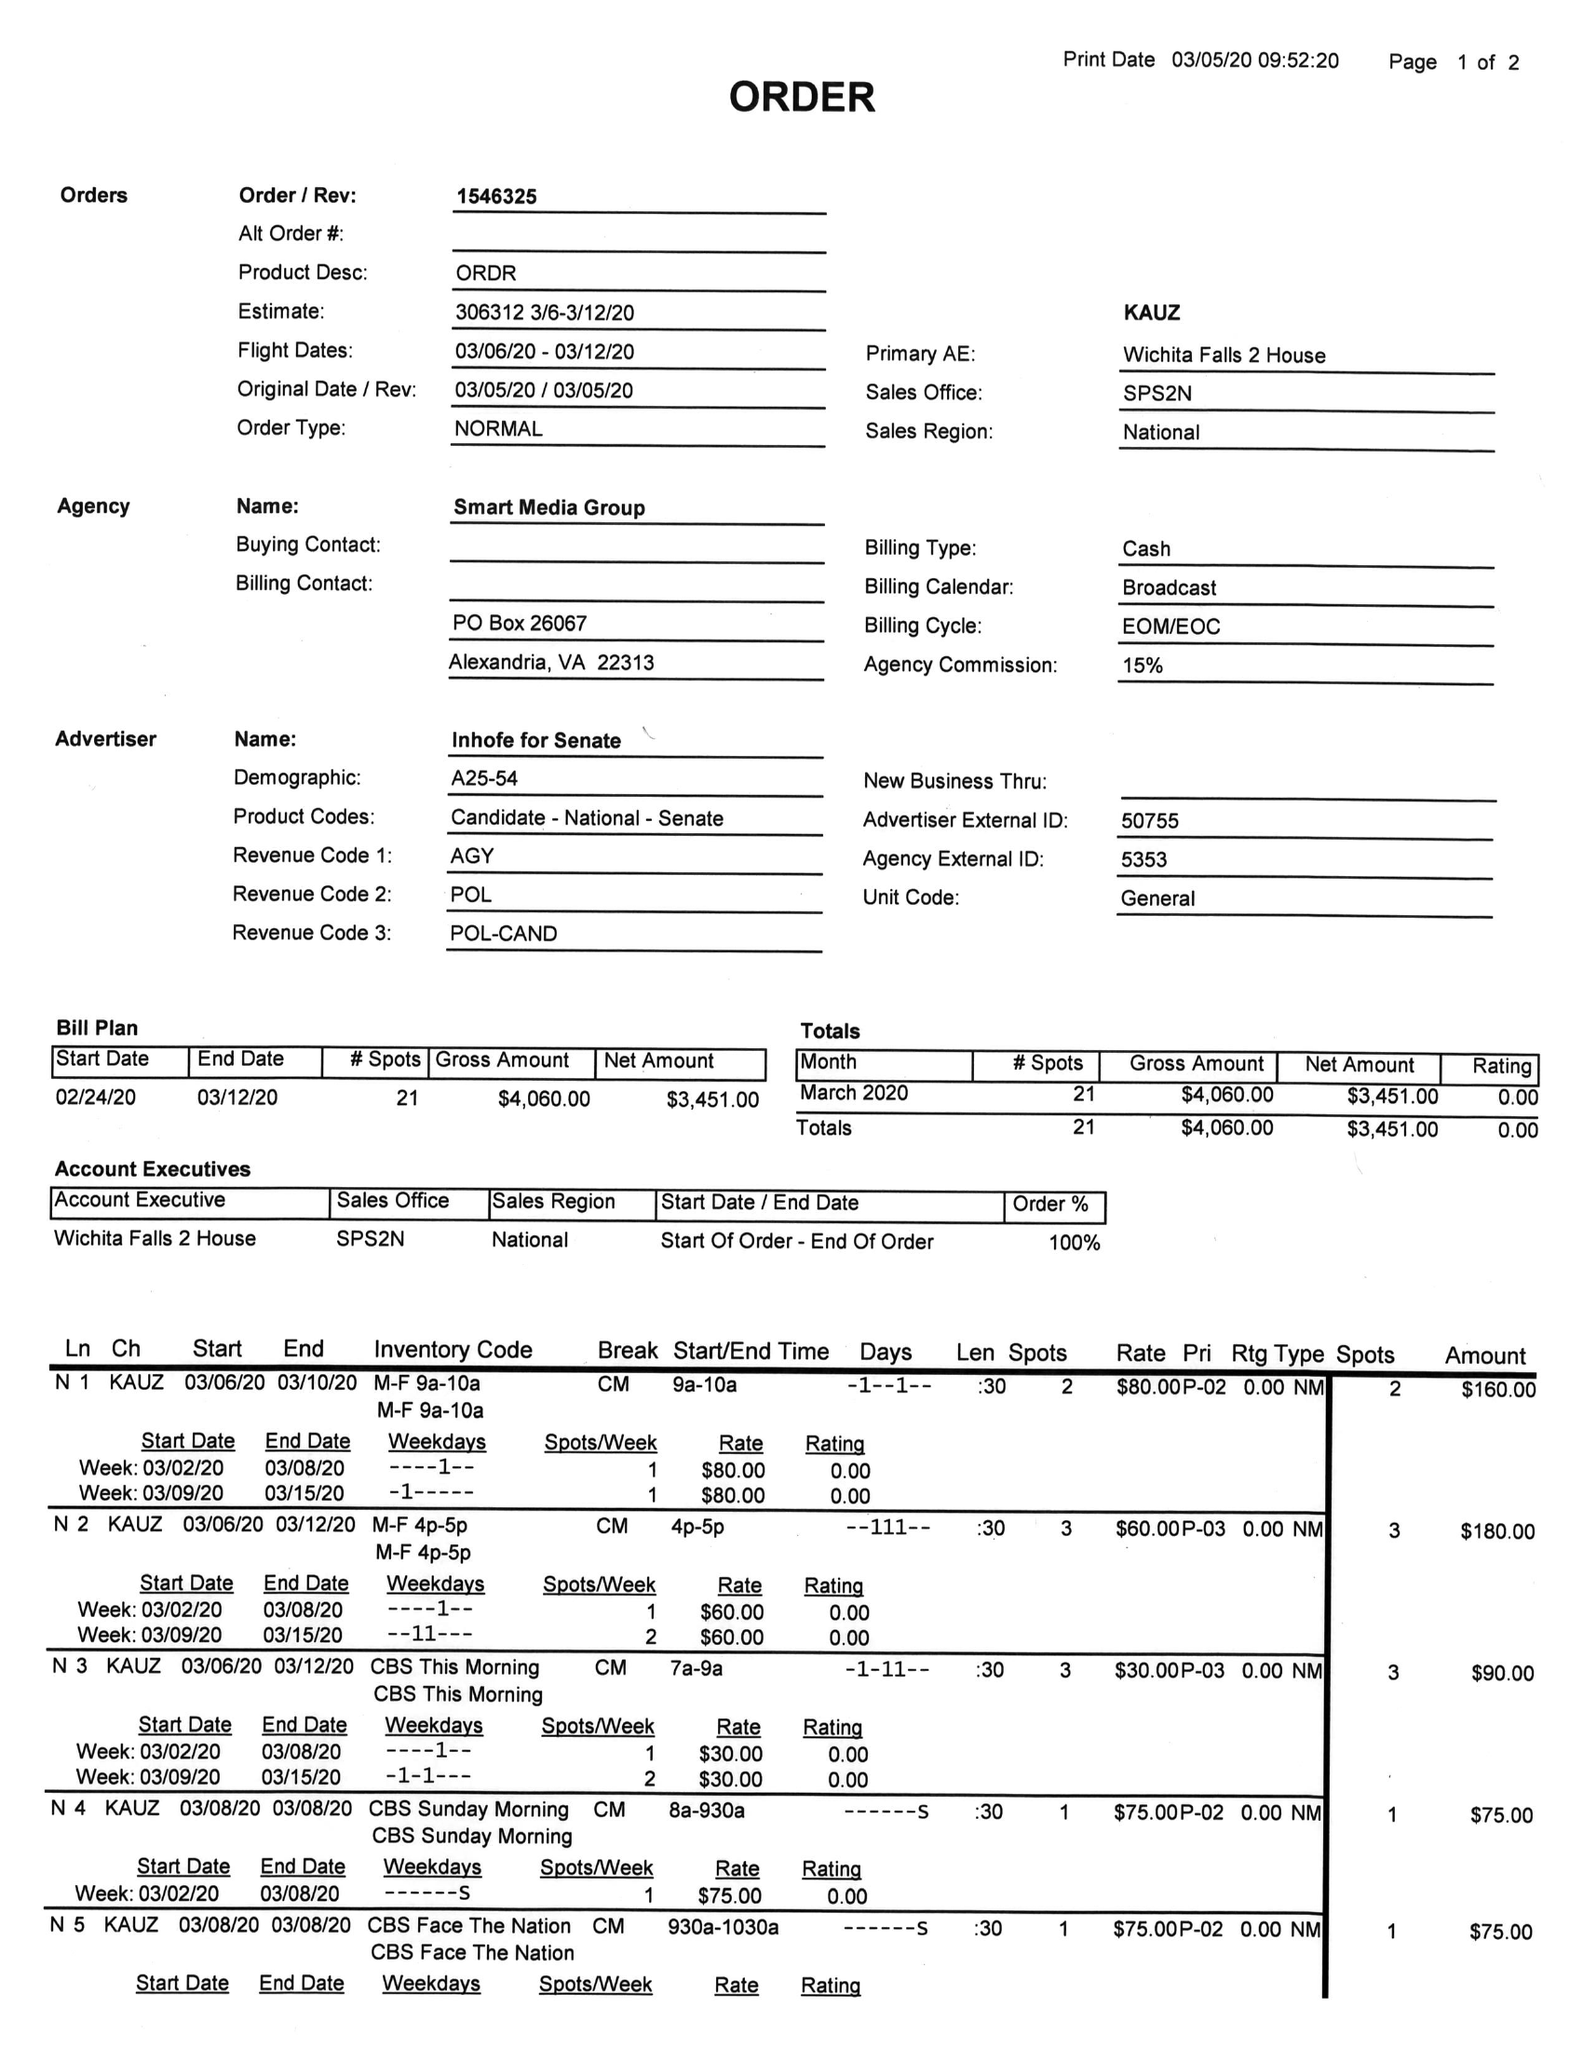What is the value for the advertiser?
Answer the question using a single word or phrase. INHOFE FOR SENATE 